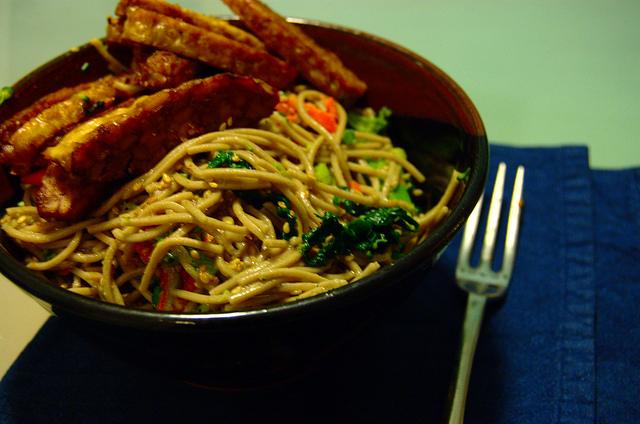What is visible?
Keep it brief. Food. What kind of cuisine is this?
Answer briefly. Chinese. Where is the fork?
Write a very short answer. Right of bowl. Forks or chopsticks?
Concise answer only. Forks. What is next to the bowl?
Write a very short answer. Fork. 